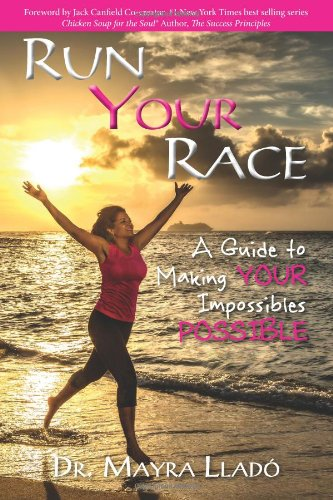Who wrote this book? The book 'Run Your Race: A Guide to Making Your Impossibles Possible' is authored by Dr. Mayra Llado. She has contributed her expert insights to guide readers through achieving their goals. 